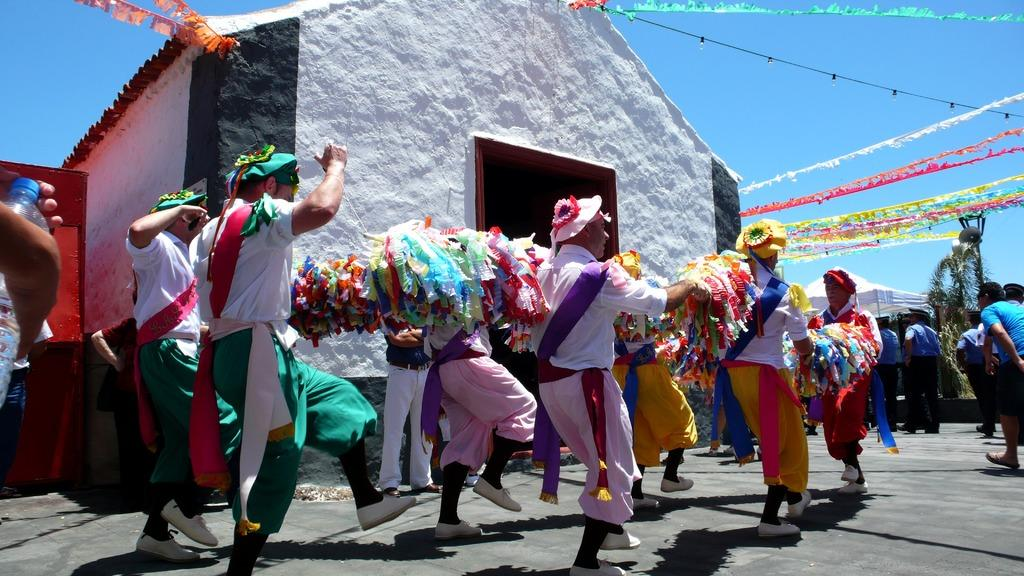How many people are in the image? There is a group of people in the image, but the exact number is not specified. What are the people doing in the image? The people are standing on the ground in the image. Can you describe the clothing of the people in the image? The people are wearing different dresses in the image. What can be seen in the background of the image? There is a tree, a shed, ribbons, a building, and the sky visible in the background of the image. Are there any cobwebs visible on the tree in the image? There is no mention of cobwebs in the provided facts, so we cannot determine if any are visible on the tree in the image. 